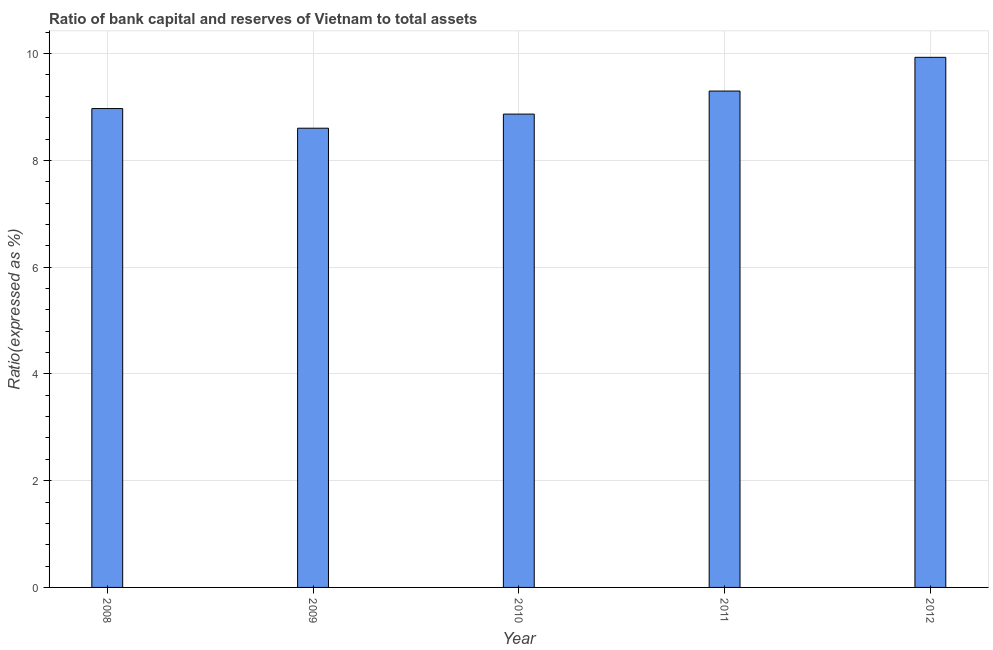Does the graph contain any zero values?
Make the answer very short. No. Does the graph contain grids?
Offer a very short reply. Yes. What is the title of the graph?
Ensure brevity in your answer.  Ratio of bank capital and reserves of Vietnam to total assets. What is the label or title of the X-axis?
Ensure brevity in your answer.  Year. What is the label or title of the Y-axis?
Offer a terse response. Ratio(expressed as %). What is the bank capital to assets ratio in 2012?
Offer a terse response. 9.93. Across all years, what is the maximum bank capital to assets ratio?
Offer a very short reply. 9.93. Across all years, what is the minimum bank capital to assets ratio?
Your answer should be very brief. 8.6. In which year was the bank capital to assets ratio minimum?
Give a very brief answer. 2009. What is the sum of the bank capital to assets ratio?
Your answer should be very brief. 45.67. What is the difference between the bank capital to assets ratio in 2008 and 2011?
Keep it short and to the point. -0.33. What is the average bank capital to assets ratio per year?
Provide a short and direct response. 9.13. What is the median bank capital to assets ratio?
Give a very brief answer. 8.97. In how many years, is the bank capital to assets ratio greater than 1.2 %?
Keep it short and to the point. 5. Do a majority of the years between 2009 and 2012 (inclusive) have bank capital to assets ratio greater than 8.4 %?
Offer a very short reply. Yes. What is the ratio of the bank capital to assets ratio in 2009 to that in 2012?
Keep it short and to the point. 0.87. Is the bank capital to assets ratio in 2010 less than that in 2011?
Give a very brief answer. Yes. Is the difference between the bank capital to assets ratio in 2008 and 2009 greater than the difference between any two years?
Give a very brief answer. No. What is the difference between the highest and the second highest bank capital to assets ratio?
Offer a terse response. 0.63. What is the difference between the highest and the lowest bank capital to assets ratio?
Keep it short and to the point. 1.33. How many bars are there?
Provide a short and direct response. 5. How many years are there in the graph?
Your response must be concise. 5. What is the difference between two consecutive major ticks on the Y-axis?
Keep it short and to the point. 2. Are the values on the major ticks of Y-axis written in scientific E-notation?
Provide a succinct answer. No. What is the Ratio(expressed as %) of 2008?
Your response must be concise. 8.97. What is the Ratio(expressed as %) in 2009?
Offer a very short reply. 8.6. What is the Ratio(expressed as %) in 2010?
Offer a terse response. 8.87. What is the Ratio(expressed as %) in 2011?
Keep it short and to the point. 9.3. What is the Ratio(expressed as %) in 2012?
Your response must be concise. 9.93. What is the difference between the Ratio(expressed as %) in 2008 and 2009?
Make the answer very short. 0.37. What is the difference between the Ratio(expressed as %) in 2008 and 2010?
Make the answer very short. 0.1. What is the difference between the Ratio(expressed as %) in 2008 and 2011?
Offer a very short reply. -0.33. What is the difference between the Ratio(expressed as %) in 2008 and 2012?
Make the answer very short. -0.96. What is the difference between the Ratio(expressed as %) in 2009 and 2010?
Your answer should be very brief. -0.26. What is the difference between the Ratio(expressed as %) in 2009 and 2011?
Keep it short and to the point. -0.7. What is the difference between the Ratio(expressed as %) in 2009 and 2012?
Your answer should be very brief. -1.33. What is the difference between the Ratio(expressed as %) in 2010 and 2011?
Keep it short and to the point. -0.43. What is the difference between the Ratio(expressed as %) in 2010 and 2012?
Your answer should be very brief. -1.06. What is the difference between the Ratio(expressed as %) in 2011 and 2012?
Offer a very short reply. -0.63. What is the ratio of the Ratio(expressed as %) in 2008 to that in 2009?
Make the answer very short. 1.04. What is the ratio of the Ratio(expressed as %) in 2008 to that in 2010?
Your answer should be compact. 1.01. What is the ratio of the Ratio(expressed as %) in 2008 to that in 2011?
Your answer should be very brief. 0.96. What is the ratio of the Ratio(expressed as %) in 2008 to that in 2012?
Offer a terse response. 0.9. What is the ratio of the Ratio(expressed as %) in 2009 to that in 2010?
Give a very brief answer. 0.97. What is the ratio of the Ratio(expressed as %) in 2009 to that in 2011?
Your response must be concise. 0.93. What is the ratio of the Ratio(expressed as %) in 2009 to that in 2012?
Provide a short and direct response. 0.87. What is the ratio of the Ratio(expressed as %) in 2010 to that in 2011?
Make the answer very short. 0.95. What is the ratio of the Ratio(expressed as %) in 2010 to that in 2012?
Your response must be concise. 0.89. What is the ratio of the Ratio(expressed as %) in 2011 to that in 2012?
Keep it short and to the point. 0.94. 